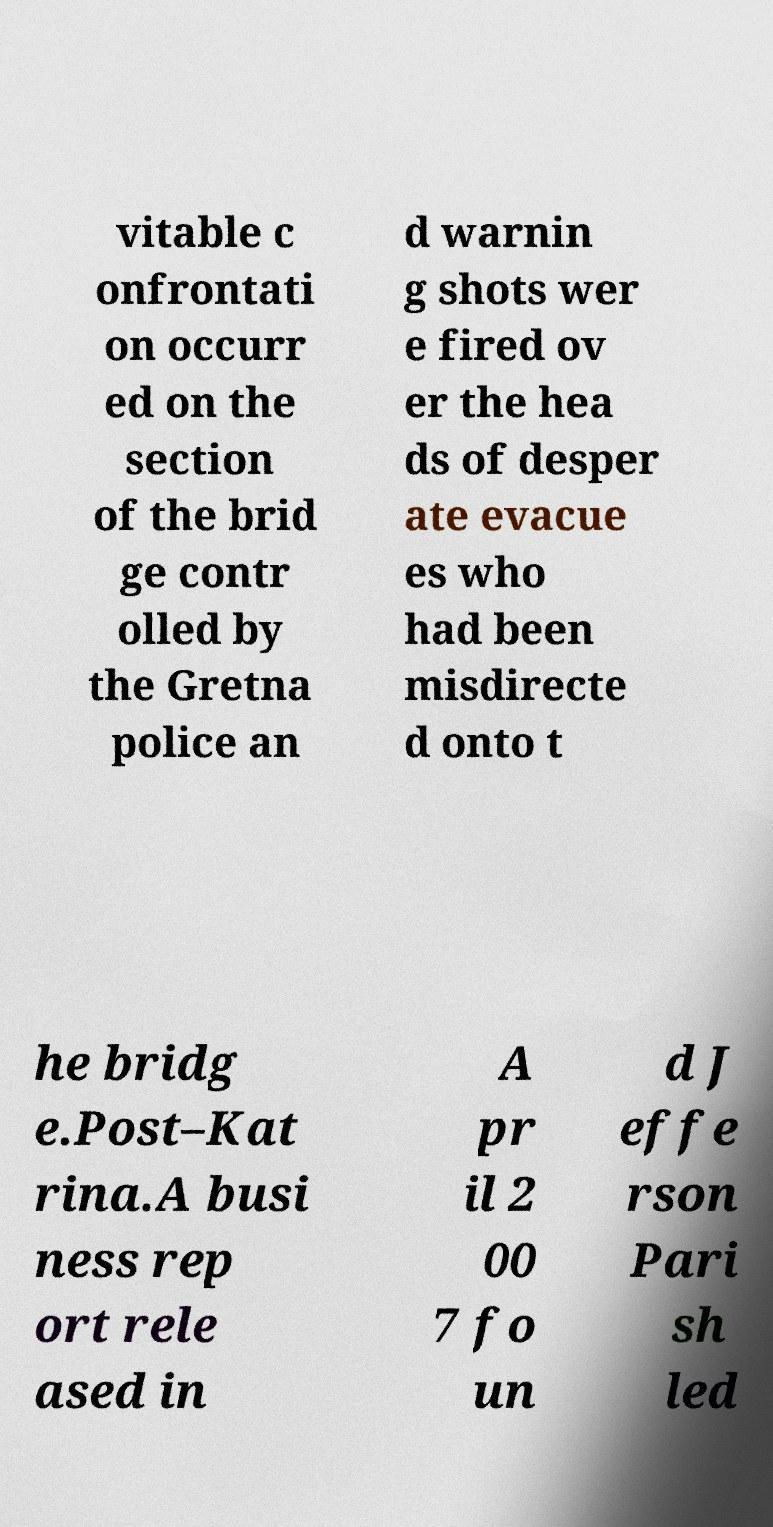Can you read and provide the text displayed in the image?This photo seems to have some interesting text. Can you extract and type it out for me? vitable c onfrontati on occurr ed on the section of the brid ge contr olled by the Gretna police an d warnin g shots wer e fired ov er the hea ds of desper ate evacue es who had been misdirecte d onto t he bridg e.Post–Kat rina.A busi ness rep ort rele ased in A pr il 2 00 7 fo un d J effe rson Pari sh led 